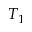Convert formula to latex. <formula><loc_0><loc_0><loc_500><loc_500>T _ { 1 }</formula> 